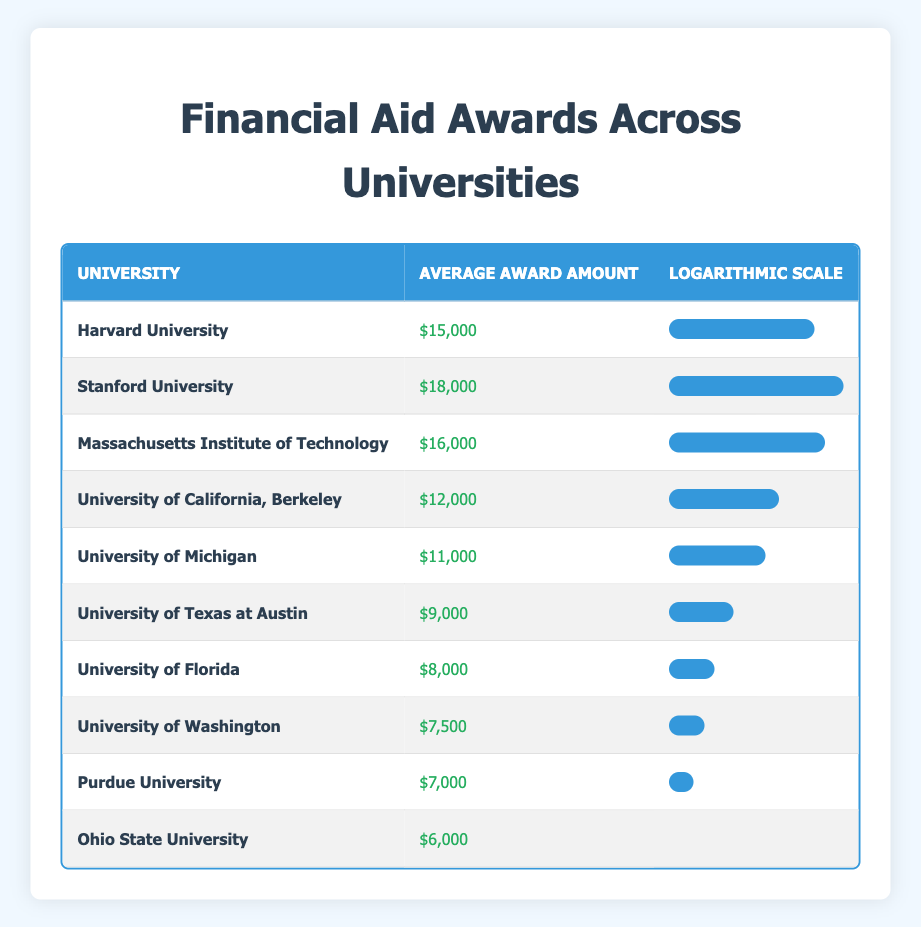What is the average award amount for Stanford University? The table shows that the average award amount for Stanford University is $18,000, which can be directly retrieved from the respective row in the table.
Answer: $18,000 Which university has the lowest average award amount? By reviewing the average award amounts in the table, Ohio State University has the lowest average award amount of $6,000.
Answer: Ohio State University What is the difference between the average award amounts of Harvard University and University of Florida? Harvard University has an average award amount of $15,000, and University of Florida has $8,000. The difference is calculated as $15,000 - $8,000 = $7,000.
Answer: $7,000 Which universities have an average award amount greater than $10,000? From the table, Harvard University ($15,000), Stanford University ($18,000), Massachusetts Institute of Technology ($16,000), and University of California, Berkeley ($12,000) all have average award amounts greater than $10,000.
Answer: Harvard University, Stanford University, Massachusetts Institute of Technology, University of California, Berkeley Is the average award amount for University of Michigan higher than that of University of Washington? From the table, University of Michigan has an average award amount of $11,000, while University of Washington has $7,500. Therefore, $11,000 is greater than $7,500, making the statement true.
Answer: Yes What is the average of the average award amounts for the three universities with the highest financial aid? The three universities with the highest financial aid amounts are Stanford University ($18,000), Massachusetts Institute of Technology ($16,000), and Harvard University ($15,000). The average is calculated as (18,000 + 16,000 + 15,000) / 3 = $16,333.33.
Answer: $16,333.33 Is there a university that offers more than $17,000 in average award amounts? By looking at the table, no university has an average award amount exceeding $18,000. The highest is $18,000 from Stanford University, so the answer to this question is false.
Answer: No What percentage of the maximum award amount does University of Texas at Austin's award represent? The maximum award amount is $18,000 (Stanford University), and University of Texas at Austin has $9,000. The percentage is calculated as (9,000 / 18,000) * 100 = 50%.
Answer: 50% 